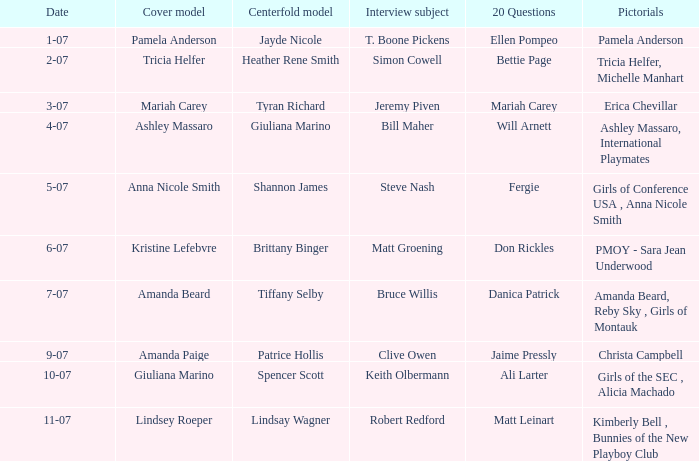Who replied to the 20 queries on 10-07? Ali Larter. 